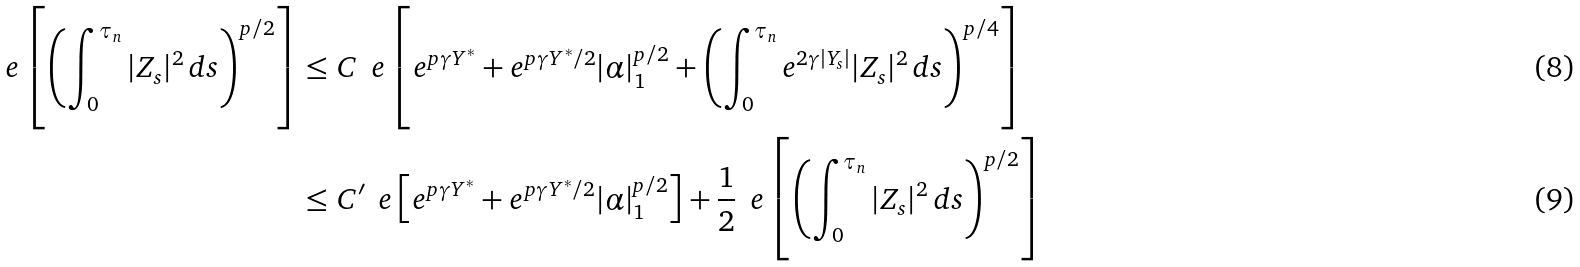Convert formula to latex. <formula><loc_0><loc_0><loc_500><loc_500>\ e \left [ \left ( \int _ { 0 } ^ { \tau _ { n } } | Z _ { s } | ^ { 2 } \, d s \right ) ^ { p / 2 } \right ] & \leq C \, \ e \left [ e ^ { p \gamma Y ^ { * } } + e ^ { p \gamma Y ^ { * } / 2 } | \alpha | _ { 1 } ^ { p / 2 } + \left ( \int _ { 0 } ^ { \tau _ { n } } e ^ { 2 \gamma | Y _ { s } | } | Z _ { s } | ^ { 2 } \, d s \right ) ^ { p / 4 } \right ] \\ & \leq C ^ { \prime } \, \ e \left [ e ^ { p \gamma Y ^ { * } } + e ^ { p \gamma Y ^ { * } / 2 } | \alpha | _ { 1 } ^ { p / 2 } \right ] + \frac { 1 } { 2 } \, \ e \left [ \left ( \int _ { 0 } ^ { \tau _ { n } } | Z _ { s } | ^ { 2 } \, d s \right ) ^ { p / 2 } \right ]</formula> 